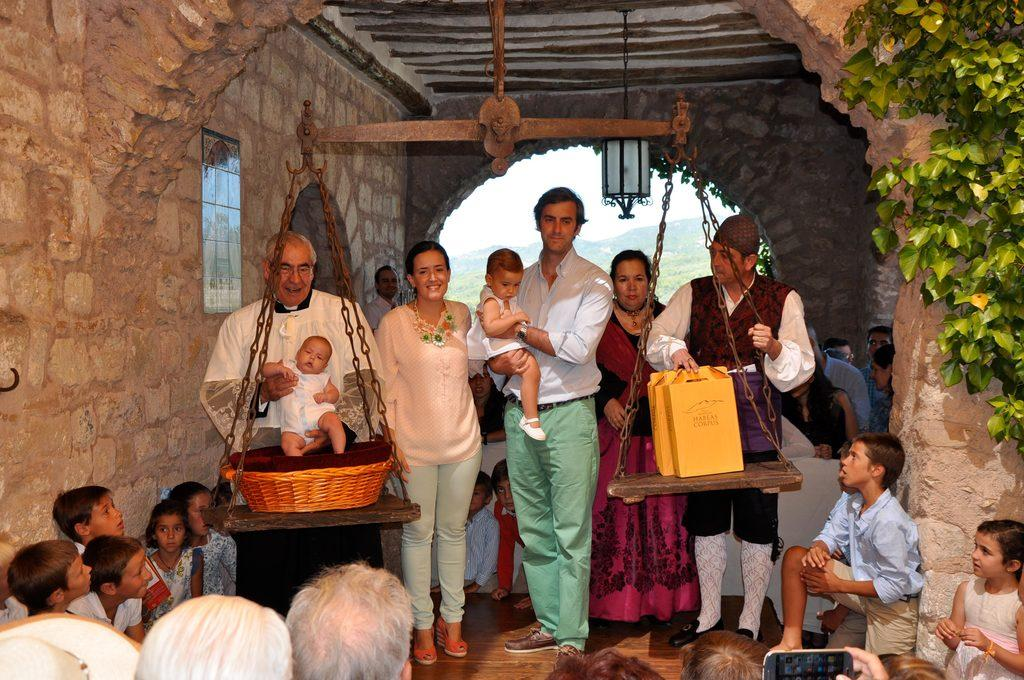What is happening in the image? There is a group of people standing in the image. What object can be seen among the people? There is a weighing machine in the image. What type of vegetation is present in the image? There are plants in the image, and they are green in color. What can be seen in the background of the image? The sky is visible in the image, and it is white in color. Are there any toys visible in the image? There are no toys present in the image. Is there a bike being ridden by someone in the image? There is no bike or anyone riding a bike in the image. 